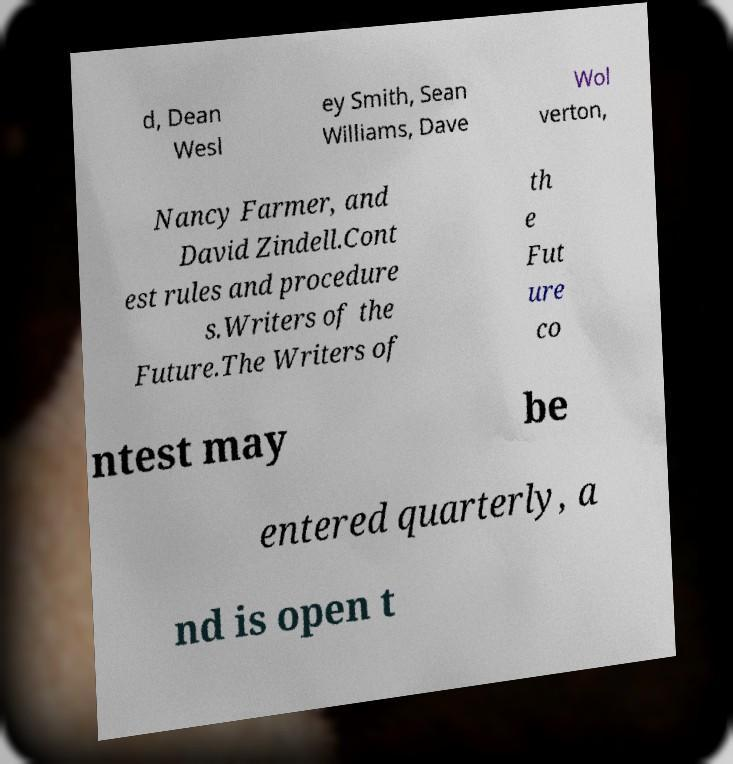Please identify and transcribe the text found in this image. d, Dean Wesl ey Smith, Sean Williams, Dave Wol verton, Nancy Farmer, and David Zindell.Cont est rules and procedure s.Writers of the Future.The Writers of th e Fut ure co ntest may be entered quarterly, a nd is open t 